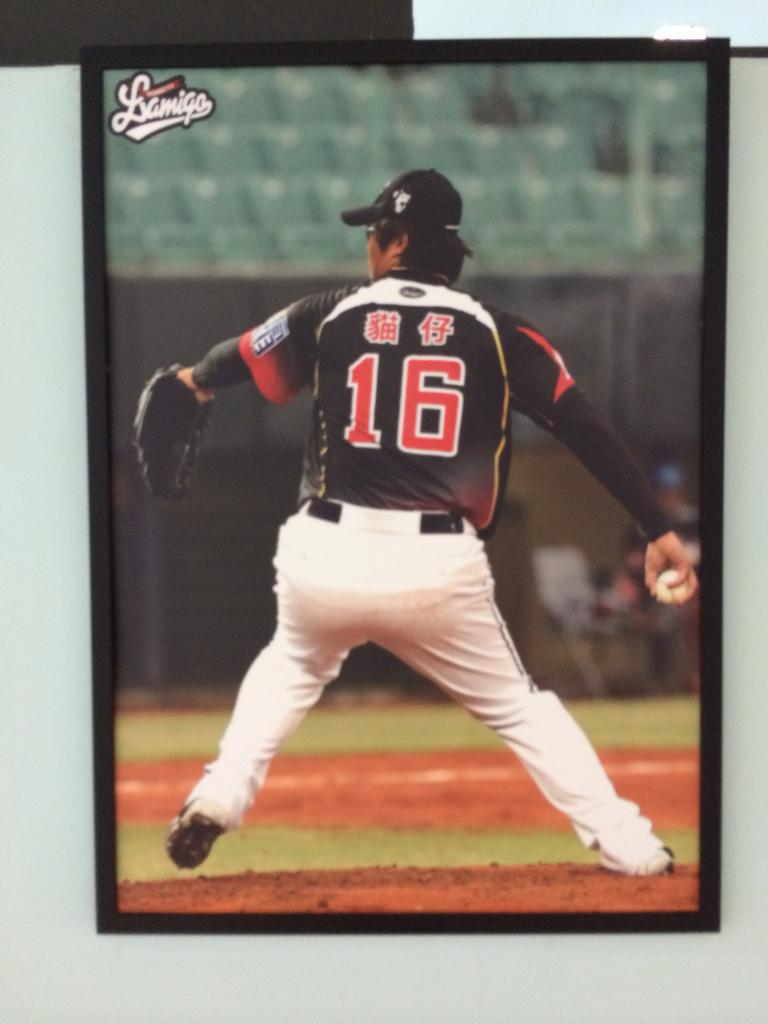Provide a one-sentence caption for the provided image. A baseball pitcher with the number 16 winds up a pitch. 